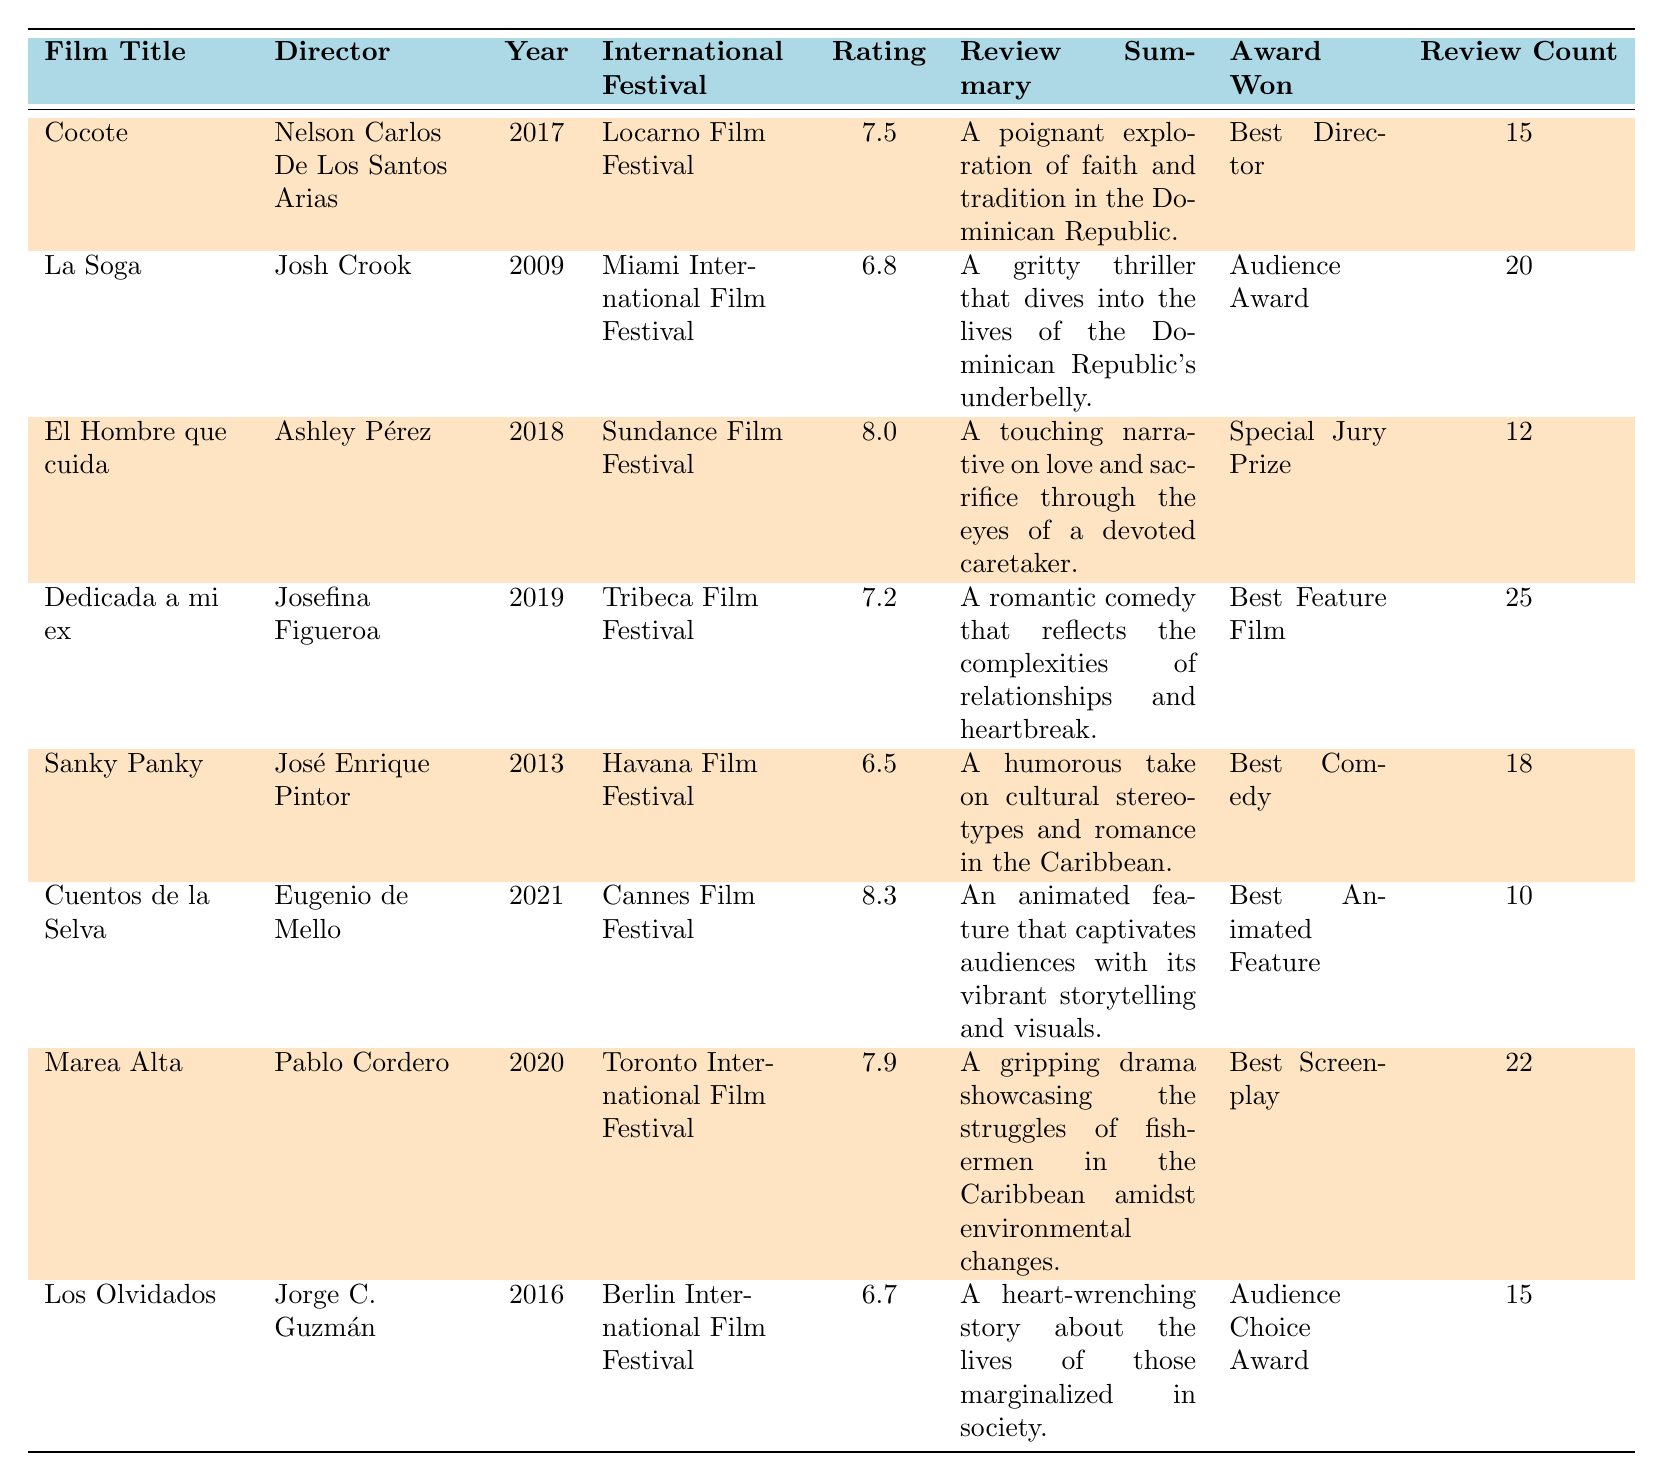What is the highest-rated Dominican film in this table? The film with the highest rating is "Cuentos de la Selva," which has a rating of 8.3.
Answer: Cuentos de la Selva How many reviews did "Dedicada a mi ex" receive? The table shows that "Dedicada a mi ex" received a total of 25 reviews.
Answer: 25 Which film won the "Best Director" award? The film "Cocote" directed by Nelson Carlos De Los Santos Arias won the "Best Director" award.
Answer: Cocote What is the average rating of the films listed in the table? To calculate the average, add up all the ratings (7.5 + 6.8 + 8.0 + 7.2 + 6.5 + 8.3 + 7.9 + 6.7 = 59.9) and divide by the total number of films (8). So, 59.9 / 8 = 7.4875, which is approximately 7.49.
Answer: 7.49 Did "Marea Alta" receive more reviews than "El Hombre que cuida"? "Marea Alta" received 22 reviews, while "El Hombre que cuida" received 12 reviews. Since 22 is greater than 12, "Marea Alta" received more reviews.
Answer: Yes What year was "La Soga" presented, and what was its rating? "La Soga" was presented in 2009, and its rating is 6.8, as per the table.
Answer: 2009, 6.8 Which film was awarded the "Special Jury Prize"? The film that won the "Special Jury Prize" is "El Hombre que cuida," directed by Ashley Pérez.
Answer: El Hombre que cuida How many awards did the film "Sanky Panky" win? The film "Sanky Panky" won one award, specifically the "Best Comedy."
Answer: 1 Which film had the fewest reviews? The film with the fewest reviews in the table is "Cuentos de la Selva," which received 10 reviews.
Answer: Cuentos de la Selva Is "Los Olvidados" rated higher than "Sanky Panky"? "Los Olvidados" has a rating of 6.7 and "Sanky Panky" has a rating of 6.5. Since 6.7 is greater than 6.5, "Los Olvidados" is rated higher.
Answer: Yes 